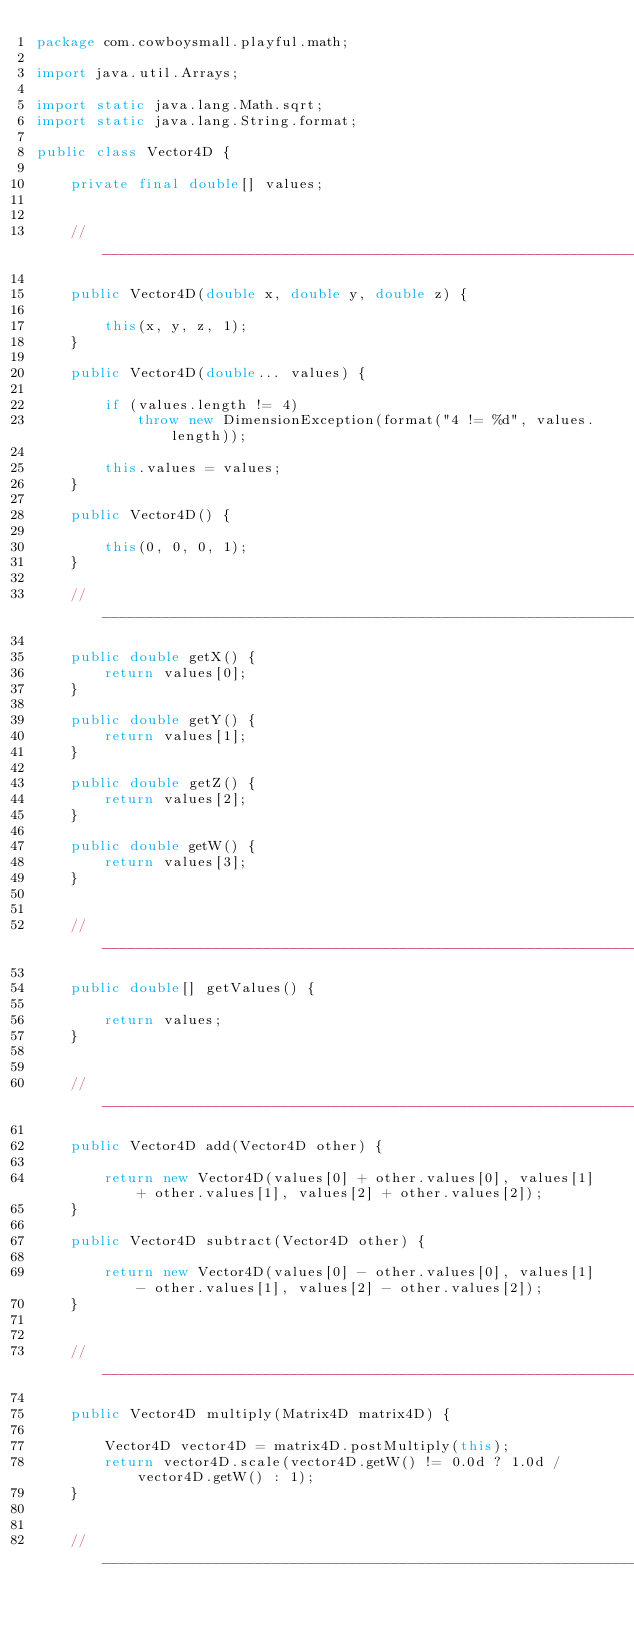Convert code to text. <code><loc_0><loc_0><loc_500><loc_500><_Java_>package com.cowboysmall.playful.math;

import java.util.Arrays;

import static java.lang.Math.sqrt;
import static java.lang.String.format;

public class Vector4D {

    private final double[] values;


    //_________________________________________________________________________

    public Vector4D(double x, double y, double z) {

        this(x, y, z, 1);
    }

    public Vector4D(double... values) {

        if (values.length != 4)
            throw new DimensionException(format("4 != %d", values.length));

        this.values = values;
    }

    public Vector4D() {

        this(0, 0, 0, 1);
    }

    //_________________________________________________________________________

    public double getX() {
        return values[0];
    }

    public double getY() {
        return values[1];
    }

    public double getZ() {
        return values[2];
    }

    public double getW() {
        return values[3];
    }


    //_________________________________________________________________________

    public double[] getValues() {

        return values;
    }


    //_________________________________________________________________________

    public Vector4D add(Vector4D other) {

        return new Vector4D(values[0] + other.values[0], values[1] + other.values[1], values[2] + other.values[2]);
    }

    public Vector4D subtract(Vector4D other) {

        return new Vector4D(values[0] - other.values[0], values[1] - other.values[1], values[2] - other.values[2]);
    }


    //_________________________________________________________________________

    public Vector4D multiply(Matrix4D matrix4D) {

        Vector4D vector4D = matrix4D.postMultiply(this);
        return vector4D.scale(vector4D.getW() != 0.0d ? 1.0d / vector4D.getW() : 1);
    }


    //_________________________________________________________________________
</code> 